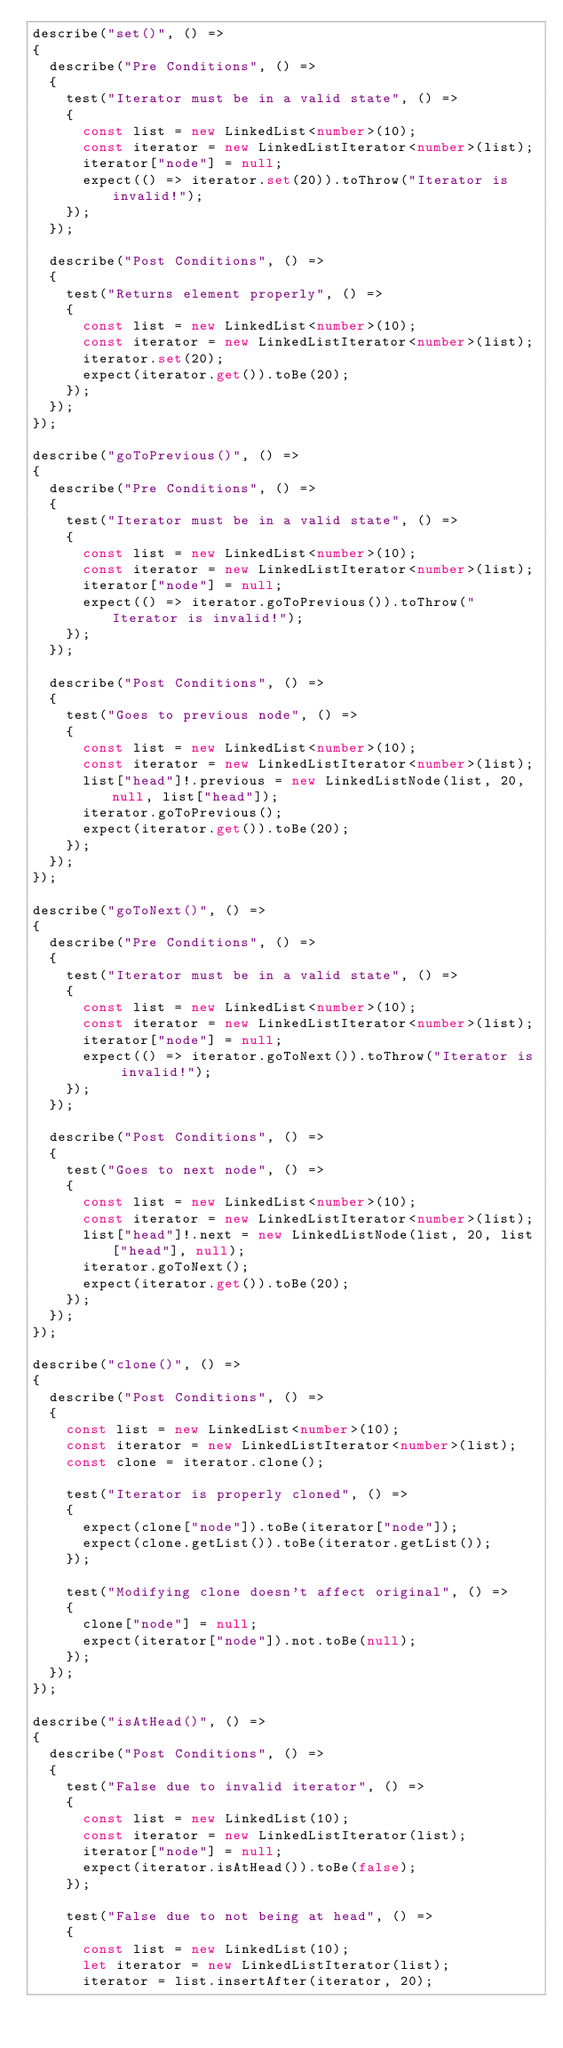<code> <loc_0><loc_0><loc_500><loc_500><_TypeScript_>describe("set()", () =>
{
  describe("Pre Conditions", () =>
  {
    test("Iterator must be in a valid state", () =>
    {
      const list = new LinkedList<number>(10);
      const iterator = new LinkedListIterator<number>(list);
      iterator["node"] = null;
      expect(() => iterator.set(20)).toThrow("Iterator is invalid!");
    });
  });

  describe("Post Conditions", () =>
  {
    test("Returns element properly", () =>
    {
      const list = new LinkedList<number>(10);
      const iterator = new LinkedListIterator<number>(list);
      iterator.set(20);
      expect(iterator.get()).toBe(20);
    });
  });
});

describe("goToPrevious()", () =>
{
  describe("Pre Conditions", () =>
  {
    test("Iterator must be in a valid state", () =>
    {
      const list = new LinkedList<number>(10);
      const iterator = new LinkedListIterator<number>(list);
      iterator["node"] = null;
      expect(() => iterator.goToPrevious()).toThrow("Iterator is invalid!");
    });
  });

  describe("Post Conditions", () =>
  {
    test("Goes to previous node", () =>
    {
      const list = new LinkedList<number>(10);
      const iterator = new LinkedListIterator<number>(list);
      list["head"]!.previous = new LinkedListNode(list, 20, null, list["head"]);
      iterator.goToPrevious();
      expect(iterator.get()).toBe(20);
    });
  });
});

describe("goToNext()", () =>
{
  describe("Pre Conditions", () =>
  {
    test("Iterator must be in a valid state", () =>
    {
      const list = new LinkedList<number>(10);
      const iterator = new LinkedListIterator<number>(list);
      iterator["node"] = null;
      expect(() => iterator.goToNext()).toThrow("Iterator is invalid!");
    });
  });

  describe("Post Conditions", () =>
  {
    test("Goes to next node", () =>
    {
      const list = new LinkedList<number>(10);
      const iterator = new LinkedListIterator<number>(list);
      list["head"]!.next = new LinkedListNode(list, 20, list["head"], null);
      iterator.goToNext();
      expect(iterator.get()).toBe(20);
    });
  });
});

describe("clone()", () =>
{
  describe("Post Conditions", () =>
  {
    const list = new LinkedList<number>(10);
    const iterator = new LinkedListIterator<number>(list);
    const clone = iterator.clone();

    test("Iterator is properly cloned", () =>
    {
      expect(clone["node"]).toBe(iterator["node"]);
      expect(clone.getList()).toBe(iterator.getList());
    });

    test("Modifying clone doesn't affect original", () =>
    {
      clone["node"] = null;
      expect(iterator["node"]).not.toBe(null);
    });
  });
});

describe("isAtHead()", () =>
{
  describe("Post Conditions", () =>
  {
    test("False due to invalid iterator", () =>
    {
      const list = new LinkedList(10);
      const iterator = new LinkedListIterator(list);
      iterator["node"] = null;
      expect(iterator.isAtHead()).toBe(false);
    });

    test("False due to not being at head", () =>
    {
      const list = new LinkedList(10);
      let iterator = new LinkedListIterator(list);
      iterator = list.insertAfter(iterator, 20);</code> 